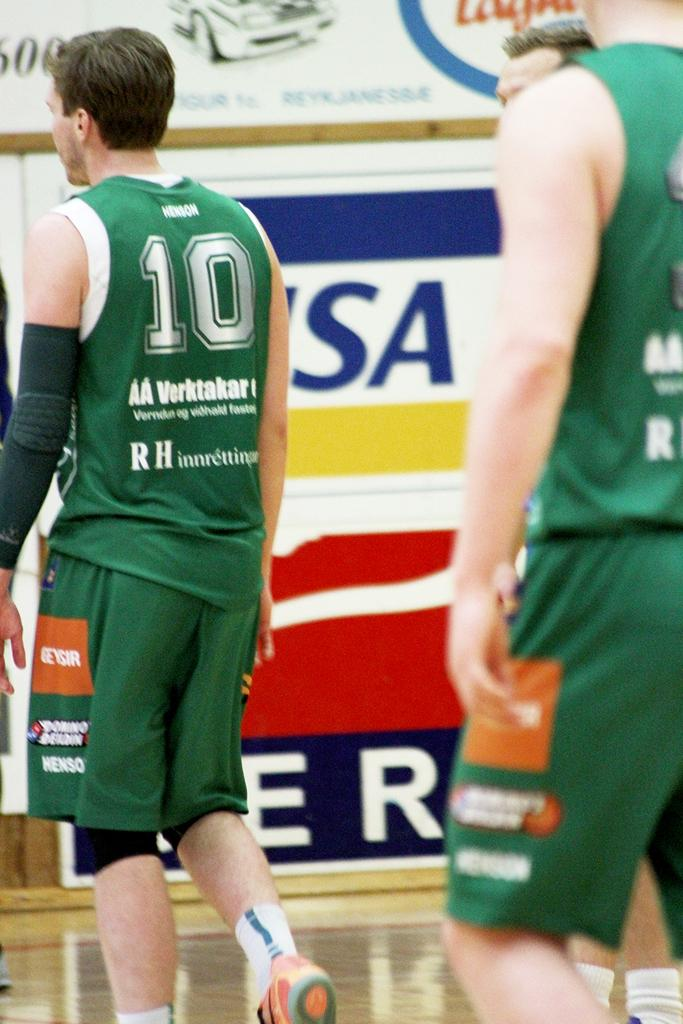<image>
Provide a brief description of the given image. Player number 10 has his back to us during a game. 